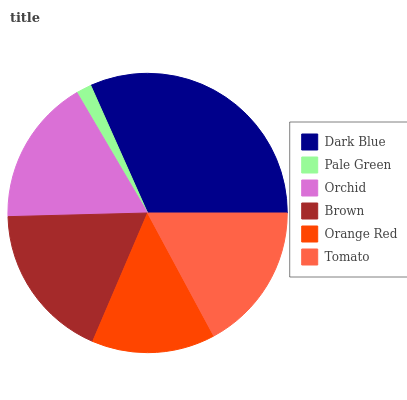Is Pale Green the minimum?
Answer yes or no. Yes. Is Dark Blue the maximum?
Answer yes or no. Yes. Is Orchid the minimum?
Answer yes or no. No. Is Orchid the maximum?
Answer yes or no. No. Is Orchid greater than Pale Green?
Answer yes or no. Yes. Is Pale Green less than Orchid?
Answer yes or no. Yes. Is Pale Green greater than Orchid?
Answer yes or no. No. Is Orchid less than Pale Green?
Answer yes or no. No. Is Tomato the high median?
Answer yes or no. Yes. Is Orchid the low median?
Answer yes or no. Yes. Is Orange Red the high median?
Answer yes or no. No. Is Tomato the low median?
Answer yes or no. No. 